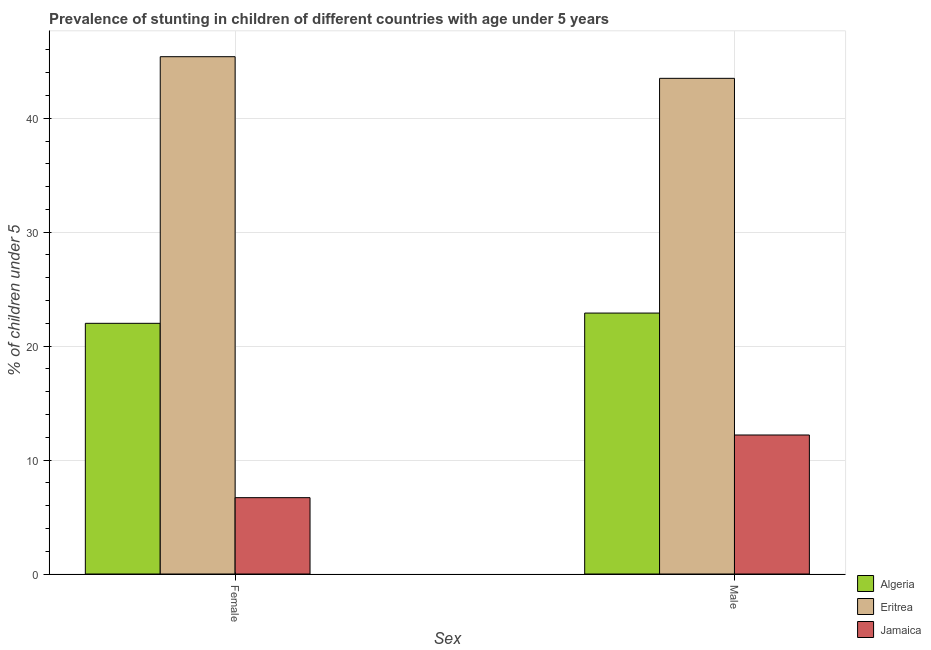How many different coloured bars are there?
Offer a very short reply. 3. Are the number of bars per tick equal to the number of legend labels?
Offer a very short reply. Yes. How many bars are there on the 2nd tick from the right?
Keep it short and to the point. 3. What is the percentage of stunted female children in Jamaica?
Keep it short and to the point. 6.7. Across all countries, what is the maximum percentage of stunted female children?
Give a very brief answer. 45.4. Across all countries, what is the minimum percentage of stunted female children?
Provide a short and direct response. 6.7. In which country was the percentage of stunted male children maximum?
Your answer should be compact. Eritrea. In which country was the percentage of stunted female children minimum?
Your answer should be very brief. Jamaica. What is the total percentage of stunted female children in the graph?
Ensure brevity in your answer.  74.1. What is the difference between the percentage of stunted female children in Algeria and that in Jamaica?
Give a very brief answer. 15.3. What is the difference between the percentage of stunted male children in Algeria and the percentage of stunted female children in Eritrea?
Ensure brevity in your answer.  -22.5. What is the average percentage of stunted female children per country?
Offer a very short reply. 24.7. What is the difference between the percentage of stunted male children and percentage of stunted female children in Eritrea?
Your response must be concise. -1.9. What is the ratio of the percentage of stunted male children in Algeria to that in Eritrea?
Keep it short and to the point. 0.53. Is the percentage of stunted female children in Algeria less than that in Jamaica?
Offer a terse response. No. In how many countries, is the percentage of stunted male children greater than the average percentage of stunted male children taken over all countries?
Offer a terse response. 1. What does the 2nd bar from the left in Female represents?
Provide a short and direct response. Eritrea. What does the 3rd bar from the right in Female represents?
Provide a succinct answer. Algeria. How many bars are there?
Your response must be concise. 6. Are all the bars in the graph horizontal?
Your answer should be very brief. No. What is the difference between two consecutive major ticks on the Y-axis?
Offer a terse response. 10. Are the values on the major ticks of Y-axis written in scientific E-notation?
Ensure brevity in your answer.  No. Does the graph contain any zero values?
Offer a terse response. No. Where does the legend appear in the graph?
Provide a short and direct response. Bottom right. How are the legend labels stacked?
Your answer should be very brief. Vertical. What is the title of the graph?
Provide a short and direct response. Prevalence of stunting in children of different countries with age under 5 years. What is the label or title of the X-axis?
Ensure brevity in your answer.  Sex. What is the label or title of the Y-axis?
Ensure brevity in your answer.   % of children under 5. What is the  % of children under 5 of Eritrea in Female?
Keep it short and to the point. 45.4. What is the  % of children under 5 in Jamaica in Female?
Offer a terse response. 6.7. What is the  % of children under 5 of Algeria in Male?
Offer a very short reply. 22.9. What is the  % of children under 5 in Eritrea in Male?
Give a very brief answer. 43.5. What is the  % of children under 5 in Jamaica in Male?
Your answer should be very brief. 12.2. Across all Sex, what is the maximum  % of children under 5 of Algeria?
Your answer should be very brief. 22.9. Across all Sex, what is the maximum  % of children under 5 of Eritrea?
Your answer should be compact. 45.4. Across all Sex, what is the maximum  % of children under 5 of Jamaica?
Keep it short and to the point. 12.2. Across all Sex, what is the minimum  % of children under 5 in Eritrea?
Keep it short and to the point. 43.5. Across all Sex, what is the minimum  % of children under 5 of Jamaica?
Your response must be concise. 6.7. What is the total  % of children under 5 in Algeria in the graph?
Ensure brevity in your answer.  44.9. What is the total  % of children under 5 of Eritrea in the graph?
Offer a very short reply. 88.9. What is the difference between the  % of children under 5 of Eritrea in Female and that in Male?
Ensure brevity in your answer.  1.9. What is the difference between the  % of children under 5 in Jamaica in Female and that in Male?
Give a very brief answer. -5.5. What is the difference between the  % of children under 5 in Algeria in Female and the  % of children under 5 in Eritrea in Male?
Make the answer very short. -21.5. What is the difference between the  % of children under 5 in Algeria in Female and the  % of children under 5 in Jamaica in Male?
Provide a short and direct response. 9.8. What is the difference between the  % of children under 5 in Eritrea in Female and the  % of children under 5 in Jamaica in Male?
Your answer should be very brief. 33.2. What is the average  % of children under 5 in Algeria per Sex?
Give a very brief answer. 22.45. What is the average  % of children under 5 in Eritrea per Sex?
Give a very brief answer. 44.45. What is the average  % of children under 5 of Jamaica per Sex?
Offer a very short reply. 9.45. What is the difference between the  % of children under 5 of Algeria and  % of children under 5 of Eritrea in Female?
Ensure brevity in your answer.  -23.4. What is the difference between the  % of children under 5 in Eritrea and  % of children under 5 in Jamaica in Female?
Your answer should be very brief. 38.7. What is the difference between the  % of children under 5 in Algeria and  % of children under 5 in Eritrea in Male?
Give a very brief answer. -20.6. What is the difference between the  % of children under 5 in Algeria and  % of children under 5 in Jamaica in Male?
Keep it short and to the point. 10.7. What is the difference between the  % of children under 5 of Eritrea and  % of children under 5 of Jamaica in Male?
Make the answer very short. 31.3. What is the ratio of the  % of children under 5 in Algeria in Female to that in Male?
Keep it short and to the point. 0.96. What is the ratio of the  % of children under 5 of Eritrea in Female to that in Male?
Give a very brief answer. 1.04. What is the ratio of the  % of children under 5 in Jamaica in Female to that in Male?
Ensure brevity in your answer.  0.55. What is the difference between the highest and the second highest  % of children under 5 of Algeria?
Provide a succinct answer. 0.9. 